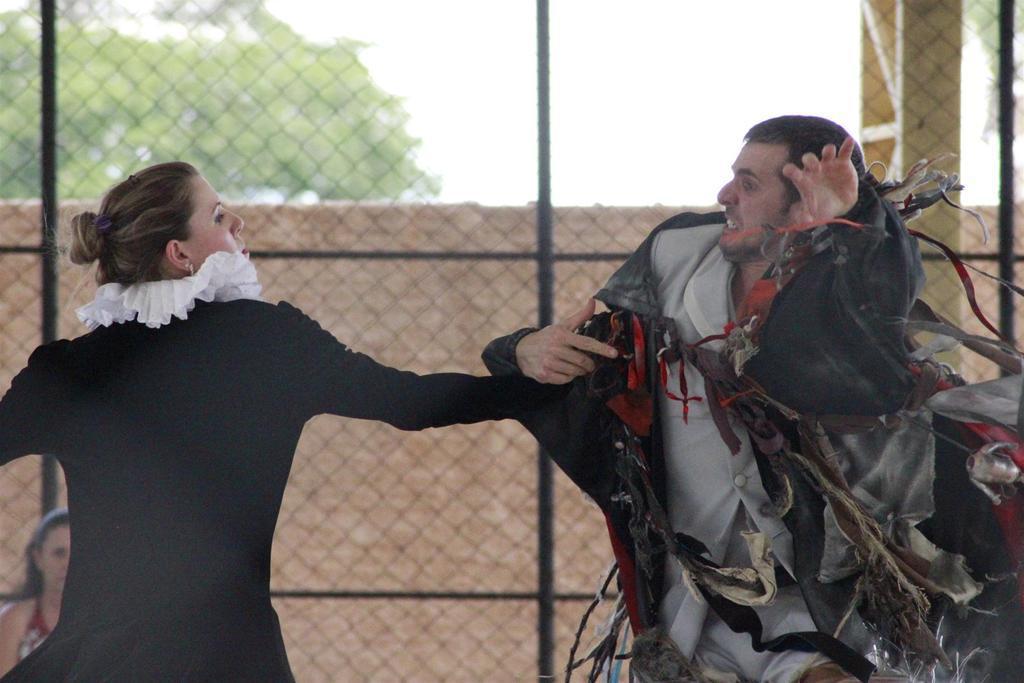Please provide a concise description of this image. In this image we can see a man and a woman standing. In the background there are trees, sky and an iron mesh. 